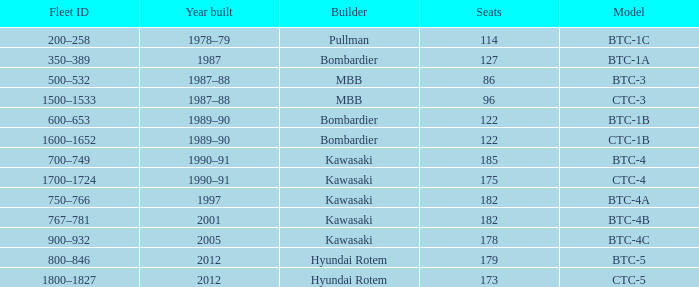How many seats does the BTC-5 model have? 179.0. 